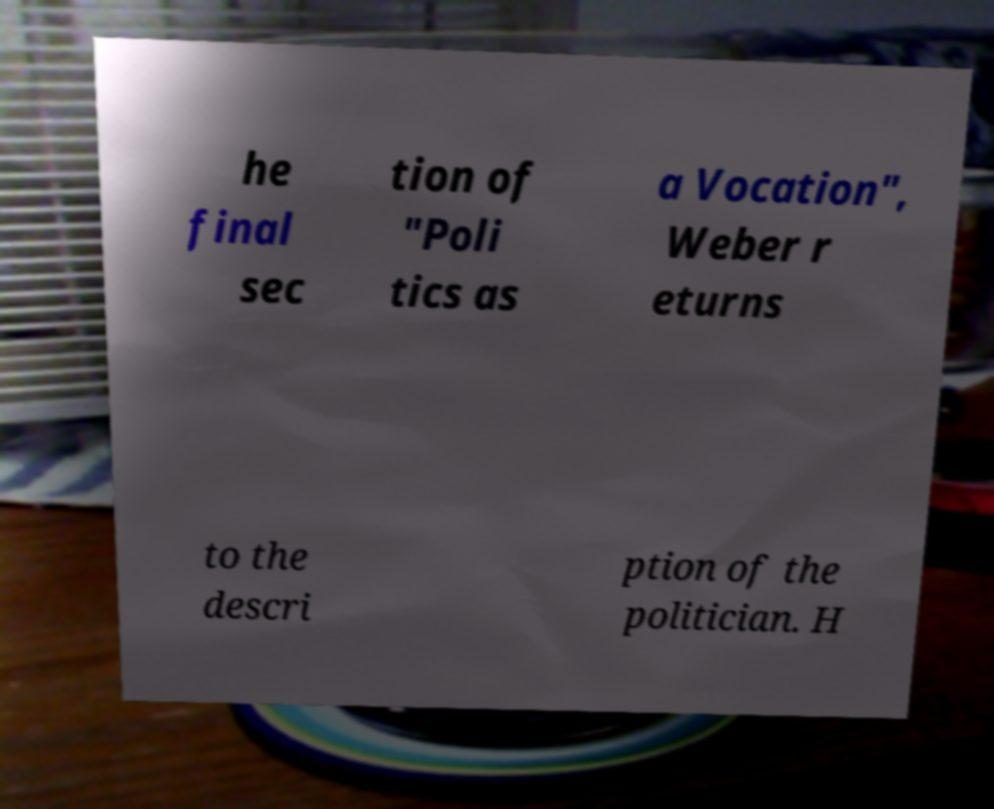For documentation purposes, I need the text within this image transcribed. Could you provide that? he final sec tion of "Poli tics as a Vocation", Weber r eturns to the descri ption of the politician. H 